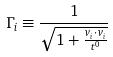<formula> <loc_0><loc_0><loc_500><loc_500>\Gamma _ { i } \equiv \frac { 1 } { \sqrt { 1 + \frac { v _ { i } \cdot v _ { i } } { t ^ { 0 } } } }</formula> 